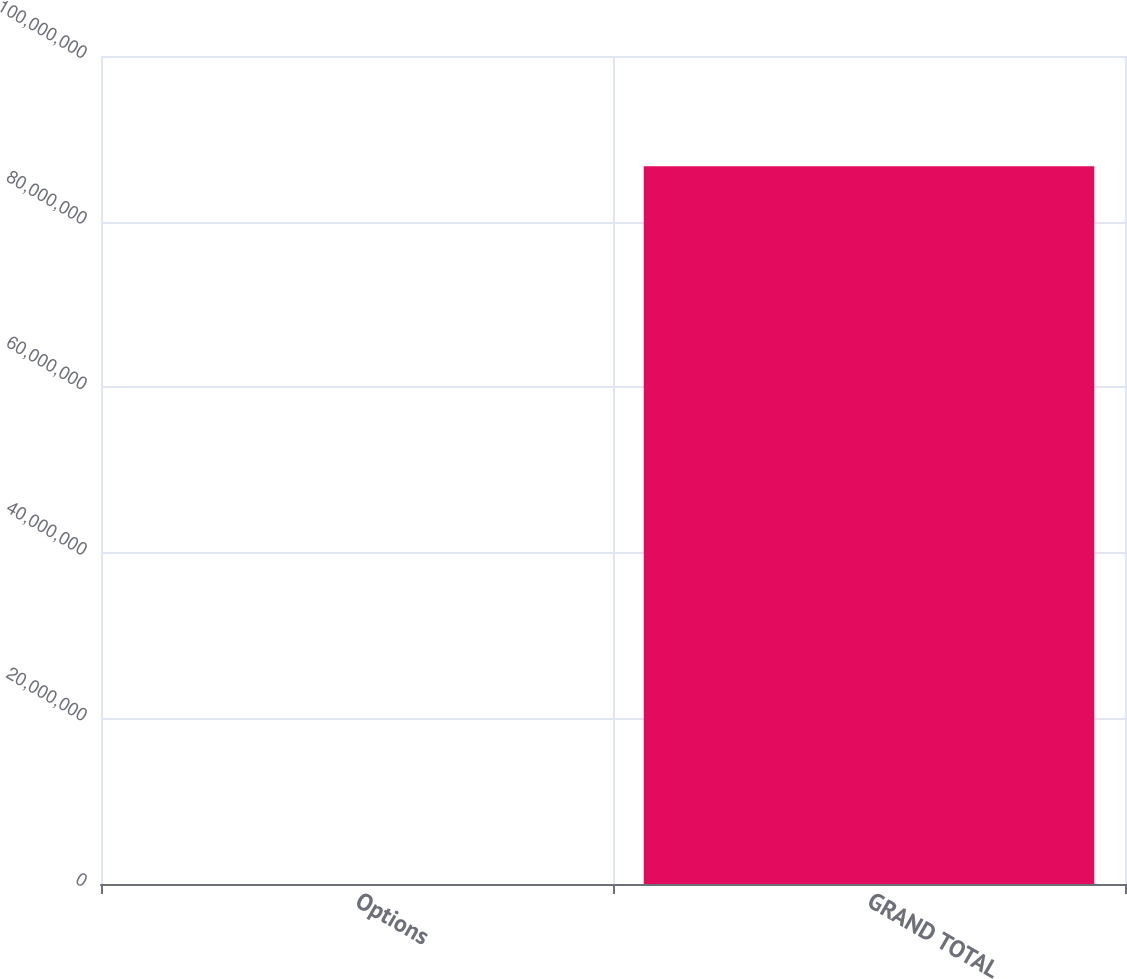Convert chart to OTSL. <chart><loc_0><loc_0><loc_500><loc_500><bar_chart><fcel>Options<fcel>GRAND TOTAL<nl><fcel>2<fcel>8.66715e+07<nl></chart> 